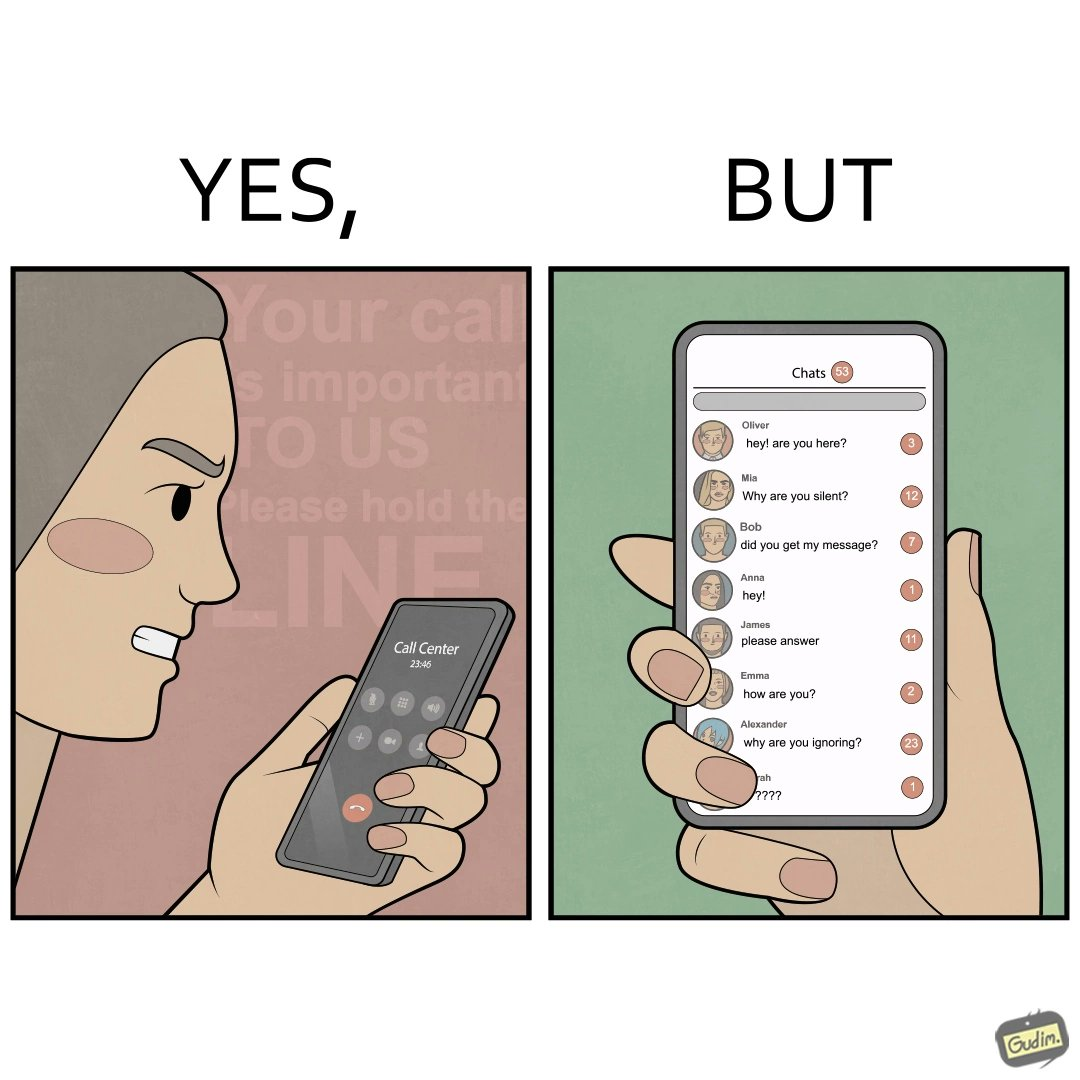Does this image contain satire or humor? Yes, this image is satirical. 